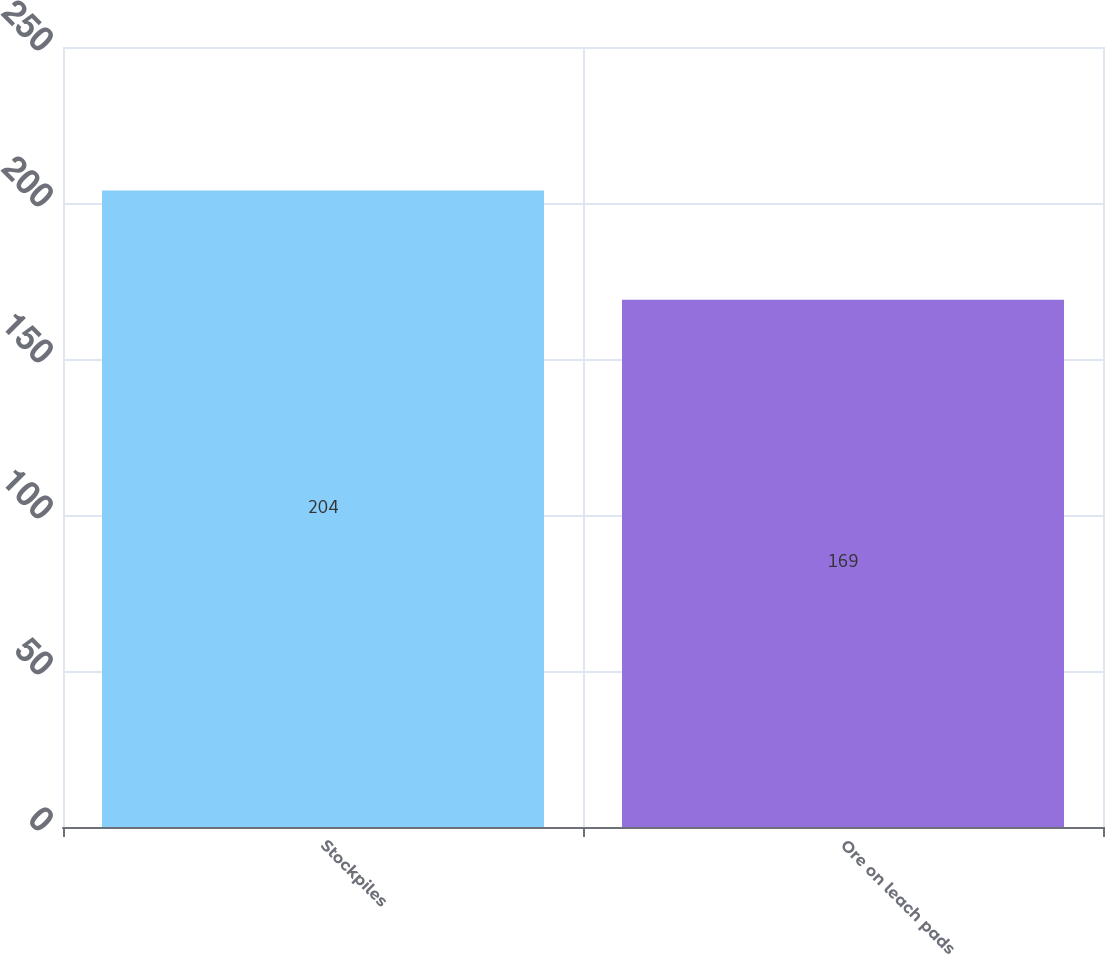Convert chart to OTSL. <chart><loc_0><loc_0><loc_500><loc_500><bar_chart><fcel>Stockpiles<fcel>Ore on leach pads<nl><fcel>204<fcel>169<nl></chart> 